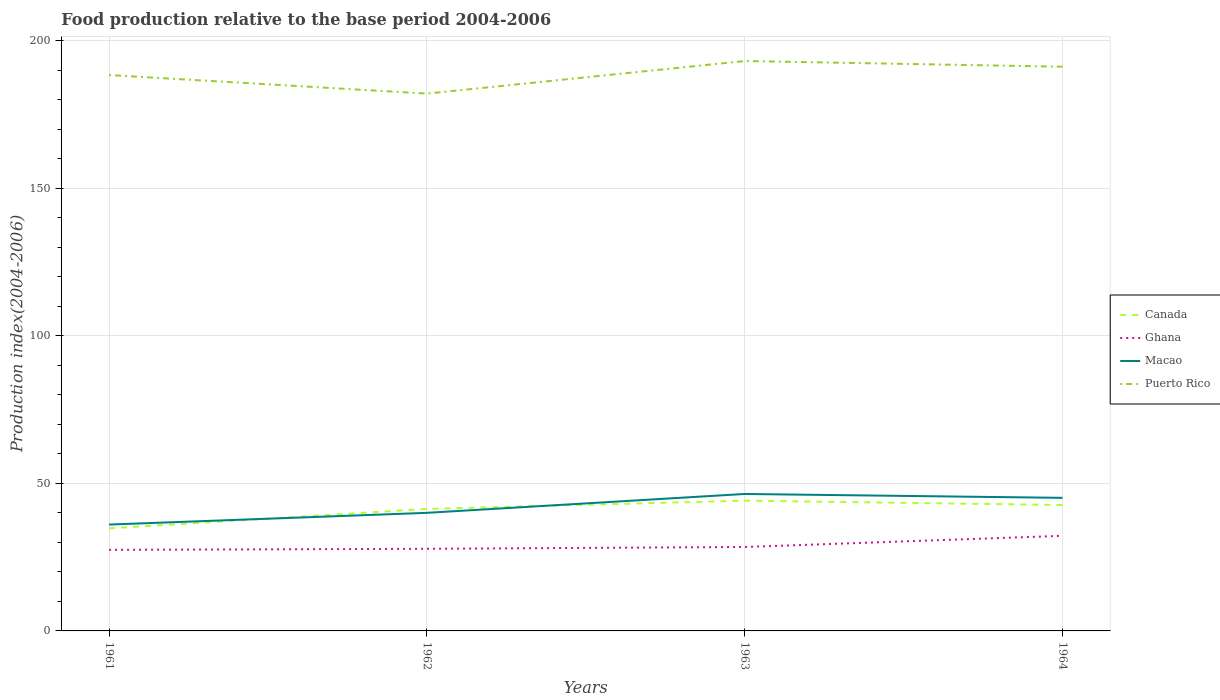Across all years, what is the maximum food production index in Puerto Rico?
Offer a very short reply. 182.01. What is the total food production index in Ghana in the graph?
Offer a very short reply. -3.79. What is the difference between the highest and the second highest food production index in Macao?
Your answer should be compact. 10.36. What is the difference between the highest and the lowest food production index in Ghana?
Give a very brief answer. 1. How many lines are there?
Ensure brevity in your answer.  4. What is the difference between two consecutive major ticks on the Y-axis?
Your answer should be compact. 50. Are the values on the major ticks of Y-axis written in scientific E-notation?
Your response must be concise. No. Does the graph contain any zero values?
Offer a very short reply. No. Where does the legend appear in the graph?
Your answer should be compact. Center right. How are the legend labels stacked?
Your answer should be very brief. Vertical. What is the title of the graph?
Your answer should be compact. Food production relative to the base period 2004-2006. What is the label or title of the X-axis?
Make the answer very short. Years. What is the label or title of the Y-axis?
Offer a terse response. Production index(2004-2006). What is the Production index(2004-2006) in Canada in 1961?
Your answer should be compact. 34.74. What is the Production index(2004-2006) of Ghana in 1961?
Your answer should be compact. 27.46. What is the Production index(2004-2006) of Macao in 1961?
Your response must be concise. 36.03. What is the Production index(2004-2006) in Puerto Rico in 1961?
Offer a terse response. 188.3. What is the Production index(2004-2006) in Canada in 1962?
Give a very brief answer. 41.33. What is the Production index(2004-2006) of Ghana in 1962?
Ensure brevity in your answer.  27.82. What is the Production index(2004-2006) in Macao in 1962?
Make the answer very short. 40. What is the Production index(2004-2006) of Puerto Rico in 1962?
Provide a succinct answer. 182.01. What is the Production index(2004-2006) in Canada in 1963?
Give a very brief answer. 44.13. What is the Production index(2004-2006) in Ghana in 1963?
Offer a terse response. 28.43. What is the Production index(2004-2006) in Macao in 1963?
Your answer should be very brief. 46.39. What is the Production index(2004-2006) in Puerto Rico in 1963?
Give a very brief answer. 193.05. What is the Production index(2004-2006) of Canada in 1964?
Provide a succinct answer. 42.65. What is the Production index(2004-2006) of Ghana in 1964?
Provide a succinct answer. 32.22. What is the Production index(2004-2006) in Macao in 1964?
Provide a short and direct response. 45.08. What is the Production index(2004-2006) in Puerto Rico in 1964?
Provide a succinct answer. 191.12. Across all years, what is the maximum Production index(2004-2006) in Canada?
Your response must be concise. 44.13. Across all years, what is the maximum Production index(2004-2006) in Ghana?
Ensure brevity in your answer.  32.22. Across all years, what is the maximum Production index(2004-2006) in Macao?
Make the answer very short. 46.39. Across all years, what is the maximum Production index(2004-2006) of Puerto Rico?
Make the answer very short. 193.05. Across all years, what is the minimum Production index(2004-2006) in Canada?
Ensure brevity in your answer.  34.74. Across all years, what is the minimum Production index(2004-2006) in Ghana?
Provide a succinct answer. 27.46. Across all years, what is the minimum Production index(2004-2006) in Macao?
Give a very brief answer. 36.03. Across all years, what is the minimum Production index(2004-2006) of Puerto Rico?
Offer a terse response. 182.01. What is the total Production index(2004-2006) in Canada in the graph?
Keep it short and to the point. 162.85. What is the total Production index(2004-2006) in Ghana in the graph?
Your answer should be very brief. 115.93. What is the total Production index(2004-2006) of Macao in the graph?
Provide a succinct answer. 167.5. What is the total Production index(2004-2006) in Puerto Rico in the graph?
Make the answer very short. 754.48. What is the difference between the Production index(2004-2006) of Canada in 1961 and that in 1962?
Your answer should be compact. -6.59. What is the difference between the Production index(2004-2006) of Ghana in 1961 and that in 1962?
Provide a short and direct response. -0.36. What is the difference between the Production index(2004-2006) of Macao in 1961 and that in 1962?
Offer a very short reply. -3.97. What is the difference between the Production index(2004-2006) of Puerto Rico in 1961 and that in 1962?
Make the answer very short. 6.29. What is the difference between the Production index(2004-2006) of Canada in 1961 and that in 1963?
Provide a succinct answer. -9.39. What is the difference between the Production index(2004-2006) in Ghana in 1961 and that in 1963?
Offer a very short reply. -0.97. What is the difference between the Production index(2004-2006) of Macao in 1961 and that in 1963?
Your answer should be compact. -10.36. What is the difference between the Production index(2004-2006) of Puerto Rico in 1961 and that in 1963?
Your answer should be compact. -4.75. What is the difference between the Production index(2004-2006) of Canada in 1961 and that in 1964?
Your answer should be compact. -7.91. What is the difference between the Production index(2004-2006) of Ghana in 1961 and that in 1964?
Ensure brevity in your answer.  -4.76. What is the difference between the Production index(2004-2006) in Macao in 1961 and that in 1964?
Your answer should be very brief. -9.05. What is the difference between the Production index(2004-2006) in Puerto Rico in 1961 and that in 1964?
Make the answer very short. -2.82. What is the difference between the Production index(2004-2006) of Canada in 1962 and that in 1963?
Offer a terse response. -2.8. What is the difference between the Production index(2004-2006) in Ghana in 1962 and that in 1963?
Your response must be concise. -0.61. What is the difference between the Production index(2004-2006) in Macao in 1962 and that in 1963?
Keep it short and to the point. -6.39. What is the difference between the Production index(2004-2006) in Puerto Rico in 1962 and that in 1963?
Ensure brevity in your answer.  -11.04. What is the difference between the Production index(2004-2006) in Canada in 1962 and that in 1964?
Provide a short and direct response. -1.32. What is the difference between the Production index(2004-2006) of Macao in 1962 and that in 1964?
Your answer should be very brief. -5.08. What is the difference between the Production index(2004-2006) of Puerto Rico in 1962 and that in 1964?
Your response must be concise. -9.11. What is the difference between the Production index(2004-2006) in Canada in 1963 and that in 1964?
Provide a succinct answer. 1.48. What is the difference between the Production index(2004-2006) of Ghana in 1963 and that in 1964?
Make the answer very short. -3.79. What is the difference between the Production index(2004-2006) in Macao in 1963 and that in 1964?
Your answer should be very brief. 1.31. What is the difference between the Production index(2004-2006) in Puerto Rico in 1963 and that in 1964?
Offer a very short reply. 1.93. What is the difference between the Production index(2004-2006) of Canada in 1961 and the Production index(2004-2006) of Ghana in 1962?
Provide a succinct answer. 6.92. What is the difference between the Production index(2004-2006) in Canada in 1961 and the Production index(2004-2006) in Macao in 1962?
Keep it short and to the point. -5.26. What is the difference between the Production index(2004-2006) in Canada in 1961 and the Production index(2004-2006) in Puerto Rico in 1962?
Your answer should be very brief. -147.27. What is the difference between the Production index(2004-2006) of Ghana in 1961 and the Production index(2004-2006) of Macao in 1962?
Your answer should be compact. -12.54. What is the difference between the Production index(2004-2006) in Ghana in 1961 and the Production index(2004-2006) in Puerto Rico in 1962?
Provide a short and direct response. -154.55. What is the difference between the Production index(2004-2006) of Macao in 1961 and the Production index(2004-2006) of Puerto Rico in 1962?
Ensure brevity in your answer.  -145.98. What is the difference between the Production index(2004-2006) of Canada in 1961 and the Production index(2004-2006) of Ghana in 1963?
Provide a short and direct response. 6.31. What is the difference between the Production index(2004-2006) of Canada in 1961 and the Production index(2004-2006) of Macao in 1963?
Ensure brevity in your answer.  -11.65. What is the difference between the Production index(2004-2006) of Canada in 1961 and the Production index(2004-2006) of Puerto Rico in 1963?
Your answer should be compact. -158.31. What is the difference between the Production index(2004-2006) of Ghana in 1961 and the Production index(2004-2006) of Macao in 1963?
Your answer should be compact. -18.93. What is the difference between the Production index(2004-2006) of Ghana in 1961 and the Production index(2004-2006) of Puerto Rico in 1963?
Provide a succinct answer. -165.59. What is the difference between the Production index(2004-2006) of Macao in 1961 and the Production index(2004-2006) of Puerto Rico in 1963?
Make the answer very short. -157.02. What is the difference between the Production index(2004-2006) in Canada in 1961 and the Production index(2004-2006) in Ghana in 1964?
Your answer should be very brief. 2.52. What is the difference between the Production index(2004-2006) in Canada in 1961 and the Production index(2004-2006) in Macao in 1964?
Keep it short and to the point. -10.34. What is the difference between the Production index(2004-2006) in Canada in 1961 and the Production index(2004-2006) in Puerto Rico in 1964?
Offer a terse response. -156.38. What is the difference between the Production index(2004-2006) of Ghana in 1961 and the Production index(2004-2006) of Macao in 1964?
Your answer should be very brief. -17.62. What is the difference between the Production index(2004-2006) in Ghana in 1961 and the Production index(2004-2006) in Puerto Rico in 1964?
Provide a short and direct response. -163.66. What is the difference between the Production index(2004-2006) of Macao in 1961 and the Production index(2004-2006) of Puerto Rico in 1964?
Offer a terse response. -155.09. What is the difference between the Production index(2004-2006) in Canada in 1962 and the Production index(2004-2006) in Macao in 1963?
Keep it short and to the point. -5.06. What is the difference between the Production index(2004-2006) of Canada in 1962 and the Production index(2004-2006) of Puerto Rico in 1963?
Offer a very short reply. -151.72. What is the difference between the Production index(2004-2006) in Ghana in 1962 and the Production index(2004-2006) in Macao in 1963?
Keep it short and to the point. -18.57. What is the difference between the Production index(2004-2006) of Ghana in 1962 and the Production index(2004-2006) of Puerto Rico in 1963?
Keep it short and to the point. -165.23. What is the difference between the Production index(2004-2006) in Macao in 1962 and the Production index(2004-2006) in Puerto Rico in 1963?
Offer a terse response. -153.05. What is the difference between the Production index(2004-2006) in Canada in 1962 and the Production index(2004-2006) in Ghana in 1964?
Ensure brevity in your answer.  9.11. What is the difference between the Production index(2004-2006) of Canada in 1962 and the Production index(2004-2006) of Macao in 1964?
Offer a very short reply. -3.75. What is the difference between the Production index(2004-2006) in Canada in 1962 and the Production index(2004-2006) in Puerto Rico in 1964?
Offer a terse response. -149.79. What is the difference between the Production index(2004-2006) in Ghana in 1962 and the Production index(2004-2006) in Macao in 1964?
Give a very brief answer. -17.26. What is the difference between the Production index(2004-2006) of Ghana in 1962 and the Production index(2004-2006) of Puerto Rico in 1964?
Provide a short and direct response. -163.3. What is the difference between the Production index(2004-2006) in Macao in 1962 and the Production index(2004-2006) in Puerto Rico in 1964?
Your answer should be very brief. -151.12. What is the difference between the Production index(2004-2006) in Canada in 1963 and the Production index(2004-2006) in Ghana in 1964?
Keep it short and to the point. 11.91. What is the difference between the Production index(2004-2006) of Canada in 1963 and the Production index(2004-2006) of Macao in 1964?
Your answer should be very brief. -0.95. What is the difference between the Production index(2004-2006) of Canada in 1963 and the Production index(2004-2006) of Puerto Rico in 1964?
Provide a short and direct response. -146.99. What is the difference between the Production index(2004-2006) of Ghana in 1963 and the Production index(2004-2006) of Macao in 1964?
Offer a terse response. -16.65. What is the difference between the Production index(2004-2006) of Ghana in 1963 and the Production index(2004-2006) of Puerto Rico in 1964?
Offer a terse response. -162.69. What is the difference between the Production index(2004-2006) in Macao in 1963 and the Production index(2004-2006) in Puerto Rico in 1964?
Offer a very short reply. -144.73. What is the average Production index(2004-2006) in Canada per year?
Make the answer very short. 40.71. What is the average Production index(2004-2006) of Ghana per year?
Your answer should be very brief. 28.98. What is the average Production index(2004-2006) of Macao per year?
Offer a terse response. 41.88. What is the average Production index(2004-2006) in Puerto Rico per year?
Make the answer very short. 188.62. In the year 1961, what is the difference between the Production index(2004-2006) of Canada and Production index(2004-2006) of Ghana?
Make the answer very short. 7.28. In the year 1961, what is the difference between the Production index(2004-2006) of Canada and Production index(2004-2006) of Macao?
Your answer should be compact. -1.29. In the year 1961, what is the difference between the Production index(2004-2006) of Canada and Production index(2004-2006) of Puerto Rico?
Give a very brief answer. -153.56. In the year 1961, what is the difference between the Production index(2004-2006) in Ghana and Production index(2004-2006) in Macao?
Provide a short and direct response. -8.57. In the year 1961, what is the difference between the Production index(2004-2006) in Ghana and Production index(2004-2006) in Puerto Rico?
Offer a very short reply. -160.84. In the year 1961, what is the difference between the Production index(2004-2006) in Macao and Production index(2004-2006) in Puerto Rico?
Make the answer very short. -152.27. In the year 1962, what is the difference between the Production index(2004-2006) of Canada and Production index(2004-2006) of Ghana?
Give a very brief answer. 13.51. In the year 1962, what is the difference between the Production index(2004-2006) in Canada and Production index(2004-2006) in Macao?
Keep it short and to the point. 1.33. In the year 1962, what is the difference between the Production index(2004-2006) in Canada and Production index(2004-2006) in Puerto Rico?
Give a very brief answer. -140.68. In the year 1962, what is the difference between the Production index(2004-2006) of Ghana and Production index(2004-2006) of Macao?
Offer a terse response. -12.18. In the year 1962, what is the difference between the Production index(2004-2006) in Ghana and Production index(2004-2006) in Puerto Rico?
Offer a very short reply. -154.19. In the year 1962, what is the difference between the Production index(2004-2006) of Macao and Production index(2004-2006) of Puerto Rico?
Provide a succinct answer. -142.01. In the year 1963, what is the difference between the Production index(2004-2006) in Canada and Production index(2004-2006) in Ghana?
Offer a very short reply. 15.7. In the year 1963, what is the difference between the Production index(2004-2006) of Canada and Production index(2004-2006) of Macao?
Your answer should be very brief. -2.26. In the year 1963, what is the difference between the Production index(2004-2006) of Canada and Production index(2004-2006) of Puerto Rico?
Provide a succinct answer. -148.92. In the year 1963, what is the difference between the Production index(2004-2006) in Ghana and Production index(2004-2006) in Macao?
Give a very brief answer. -17.96. In the year 1963, what is the difference between the Production index(2004-2006) in Ghana and Production index(2004-2006) in Puerto Rico?
Keep it short and to the point. -164.62. In the year 1963, what is the difference between the Production index(2004-2006) of Macao and Production index(2004-2006) of Puerto Rico?
Give a very brief answer. -146.66. In the year 1964, what is the difference between the Production index(2004-2006) in Canada and Production index(2004-2006) in Ghana?
Your response must be concise. 10.43. In the year 1964, what is the difference between the Production index(2004-2006) of Canada and Production index(2004-2006) of Macao?
Your answer should be very brief. -2.43. In the year 1964, what is the difference between the Production index(2004-2006) of Canada and Production index(2004-2006) of Puerto Rico?
Give a very brief answer. -148.47. In the year 1964, what is the difference between the Production index(2004-2006) of Ghana and Production index(2004-2006) of Macao?
Your response must be concise. -12.86. In the year 1964, what is the difference between the Production index(2004-2006) of Ghana and Production index(2004-2006) of Puerto Rico?
Give a very brief answer. -158.9. In the year 1964, what is the difference between the Production index(2004-2006) in Macao and Production index(2004-2006) in Puerto Rico?
Make the answer very short. -146.04. What is the ratio of the Production index(2004-2006) of Canada in 1961 to that in 1962?
Your answer should be compact. 0.84. What is the ratio of the Production index(2004-2006) of Ghana in 1961 to that in 1962?
Provide a succinct answer. 0.99. What is the ratio of the Production index(2004-2006) in Macao in 1961 to that in 1962?
Your response must be concise. 0.9. What is the ratio of the Production index(2004-2006) in Puerto Rico in 1961 to that in 1962?
Keep it short and to the point. 1.03. What is the ratio of the Production index(2004-2006) of Canada in 1961 to that in 1963?
Provide a succinct answer. 0.79. What is the ratio of the Production index(2004-2006) of Ghana in 1961 to that in 1963?
Your response must be concise. 0.97. What is the ratio of the Production index(2004-2006) of Macao in 1961 to that in 1963?
Offer a very short reply. 0.78. What is the ratio of the Production index(2004-2006) of Puerto Rico in 1961 to that in 1963?
Provide a short and direct response. 0.98. What is the ratio of the Production index(2004-2006) of Canada in 1961 to that in 1964?
Provide a succinct answer. 0.81. What is the ratio of the Production index(2004-2006) in Ghana in 1961 to that in 1964?
Your response must be concise. 0.85. What is the ratio of the Production index(2004-2006) of Macao in 1961 to that in 1964?
Offer a terse response. 0.8. What is the ratio of the Production index(2004-2006) of Puerto Rico in 1961 to that in 1964?
Offer a very short reply. 0.99. What is the ratio of the Production index(2004-2006) in Canada in 1962 to that in 1963?
Your answer should be compact. 0.94. What is the ratio of the Production index(2004-2006) of Ghana in 1962 to that in 1963?
Offer a very short reply. 0.98. What is the ratio of the Production index(2004-2006) of Macao in 1962 to that in 1963?
Provide a short and direct response. 0.86. What is the ratio of the Production index(2004-2006) of Puerto Rico in 1962 to that in 1963?
Keep it short and to the point. 0.94. What is the ratio of the Production index(2004-2006) in Canada in 1962 to that in 1964?
Ensure brevity in your answer.  0.97. What is the ratio of the Production index(2004-2006) in Ghana in 1962 to that in 1964?
Ensure brevity in your answer.  0.86. What is the ratio of the Production index(2004-2006) of Macao in 1962 to that in 1964?
Your response must be concise. 0.89. What is the ratio of the Production index(2004-2006) in Puerto Rico in 1962 to that in 1964?
Give a very brief answer. 0.95. What is the ratio of the Production index(2004-2006) in Canada in 1963 to that in 1964?
Offer a very short reply. 1.03. What is the ratio of the Production index(2004-2006) in Ghana in 1963 to that in 1964?
Ensure brevity in your answer.  0.88. What is the ratio of the Production index(2004-2006) of Macao in 1963 to that in 1964?
Make the answer very short. 1.03. What is the ratio of the Production index(2004-2006) in Puerto Rico in 1963 to that in 1964?
Provide a short and direct response. 1.01. What is the difference between the highest and the second highest Production index(2004-2006) in Canada?
Ensure brevity in your answer.  1.48. What is the difference between the highest and the second highest Production index(2004-2006) of Ghana?
Ensure brevity in your answer.  3.79. What is the difference between the highest and the second highest Production index(2004-2006) in Macao?
Keep it short and to the point. 1.31. What is the difference between the highest and the second highest Production index(2004-2006) of Puerto Rico?
Keep it short and to the point. 1.93. What is the difference between the highest and the lowest Production index(2004-2006) in Canada?
Provide a short and direct response. 9.39. What is the difference between the highest and the lowest Production index(2004-2006) of Ghana?
Give a very brief answer. 4.76. What is the difference between the highest and the lowest Production index(2004-2006) of Macao?
Offer a very short reply. 10.36. What is the difference between the highest and the lowest Production index(2004-2006) in Puerto Rico?
Keep it short and to the point. 11.04. 